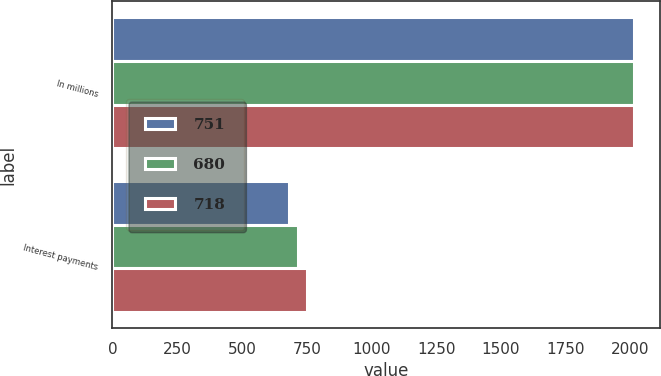Convert chart. <chart><loc_0><loc_0><loc_500><loc_500><stacked_bar_chart><ecel><fcel>In millions<fcel>Interest payments<nl><fcel>751<fcel>2015<fcel>680<nl><fcel>680<fcel>2014<fcel>718<nl><fcel>718<fcel>2013<fcel>751<nl></chart> 